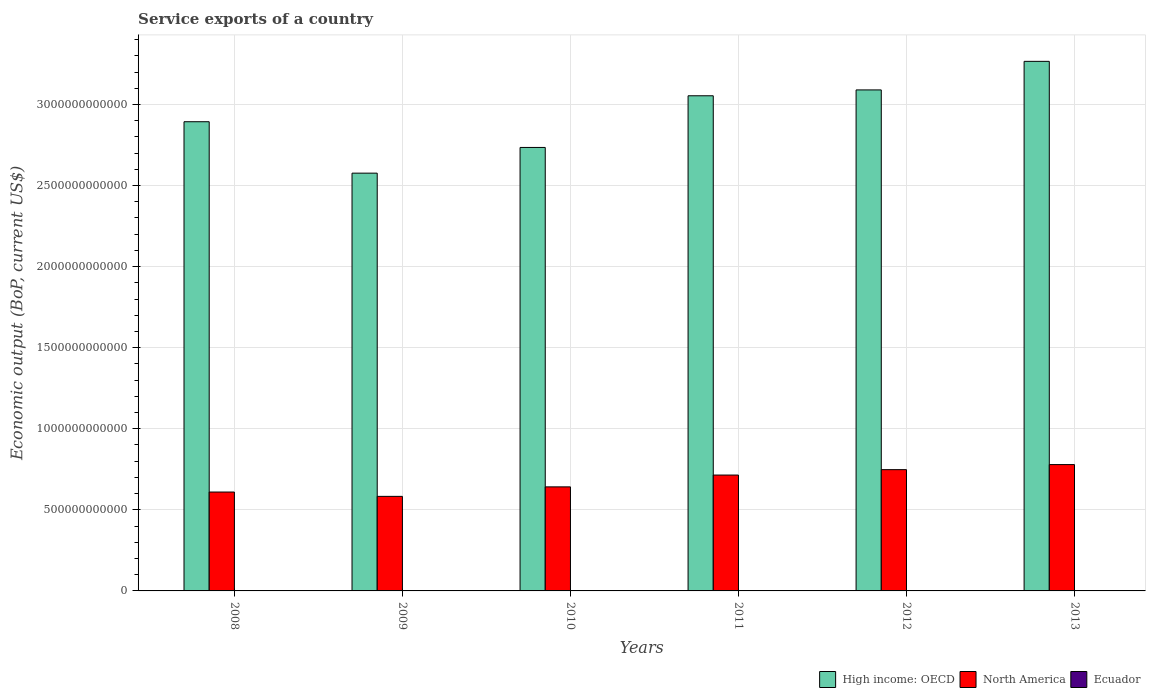How many different coloured bars are there?
Ensure brevity in your answer.  3. Are the number of bars per tick equal to the number of legend labels?
Offer a terse response. Yes. What is the label of the 1st group of bars from the left?
Ensure brevity in your answer.  2008. In how many cases, is the number of bars for a given year not equal to the number of legend labels?
Your answer should be compact. 0. What is the service exports in Ecuador in 2011?
Ensure brevity in your answer.  1.59e+09. Across all years, what is the maximum service exports in North America?
Provide a succinct answer. 7.79e+11. Across all years, what is the minimum service exports in North America?
Your answer should be very brief. 5.83e+11. In which year was the service exports in North America minimum?
Keep it short and to the point. 2009. What is the total service exports in Ecuador in the graph?
Keep it short and to the point. 9.71e+09. What is the difference between the service exports in Ecuador in 2008 and that in 2011?
Keep it short and to the point. -1.46e+08. What is the difference between the service exports in North America in 2011 and the service exports in High income: OECD in 2008?
Provide a succinct answer. -2.18e+12. What is the average service exports in North America per year?
Ensure brevity in your answer.  6.79e+11. In the year 2013, what is the difference between the service exports in High income: OECD and service exports in Ecuador?
Give a very brief answer. 3.26e+12. What is the ratio of the service exports in North America in 2011 to that in 2013?
Ensure brevity in your answer.  0.92. What is the difference between the highest and the second highest service exports in North America?
Offer a terse response. 3.12e+1. What is the difference between the highest and the lowest service exports in North America?
Your answer should be compact. 1.96e+11. In how many years, is the service exports in North America greater than the average service exports in North America taken over all years?
Provide a short and direct response. 3. Is the sum of the service exports in Ecuador in 2011 and 2012 greater than the maximum service exports in High income: OECD across all years?
Your answer should be compact. No. What does the 3rd bar from the left in 2008 represents?
Your answer should be very brief. Ecuador. Is it the case that in every year, the sum of the service exports in High income: OECD and service exports in Ecuador is greater than the service exports in North America?
Offer a very short reply. Yes. Are all the bars in the graph horizontal?
Offer a terse response. No. How many years are there in the graph?
Ensure brevity in your answer.  6. What is the difference between two consecutive major ticks on the Y-axis?
Offer a terse response. 5.00e+11. Are the values on the major ticks of Y-axis written in scientific E-notation?
Give a very brief answer. No. Does the graph contain any zero values?
Give a very brief answer. No. Does the graph contain grids?
Make the answer very short. Yes. How are the legend labels stacked?
Make the answer very short. Horizontal. What is the title of the graph?
Your answer should be very brief. Service exports of a country. What is the label or title of the Y-axis?
Offer a very short reply. Economic output (BoP, current US$). What is the Economic output (BoP, current US$) in High income: OECD in 2008?
Offer a terse response. 2.89e+12. What is the Economic output (BoP, current US$) of North America in 2008?
Your answer should be compact. 6.10e+11. What is the Economic output (BoP, current US$) in Ecuador in 2008?
Give a very brief answer. 1.45e+09. What is the Economic output (BoP, current US$) of High income: OECD in 2009?
Keep it short and to the point. 2.58e+12. What is the Economic output (BoP, current US$) of North America in 2009?
Offer a terse response. 5.83e+11. What is the Economic output (BoP, current US$) of Ecuador in 2009?
Make the answer very short. 1.34e+09. What is the Economic output (BoP, current US$) in High income: OECD in 2010?
Your response must be concise. 2.73e+12. What is the Economic output (BoP, current US$) of North America in 2010?
Ensure brevity in your answer.  6.42e+11. What is the Economic output (BoP, current US$) in Ecuador in 2010?
Provide a short and direct response. 1.48e+09. What is the Economic output (BoP, current US$) in High income: OECD in 2011?
Provide a succinct answer. 3.05e+12. What is the Economic output (BoP, current US$) of North America in 2011?
Your answer should be compact. 7.15e+11. What is the Economic output (BoP, current US$) in Ecuador in 2011?
Your answer should be very brief. 1.59e+09. What is the Economic output (BoP, current US$) of High income: OECD in 2012?
Provide a succinct answer. 3.09e+12. What is the Economic output (BoP, current US$) in North America in 2012?
Ensure brevity in your answer.  7.48e+11. What is the Economic output (BoP, current US$) in Ecuador in 2012?
Your answer should be compact. 1.81e+09. What is the Economic output (BoP, current US$) of High income: OECD in 2013?
Make the answer very short. 3.27e+12. What is the Economic output (BoP, current US$) in North America in 2013?
Offer a very short reply. 7.79e+11. What is the Economic output (BoP, current US$) in Ecuador in 2013?
Provide a short and direct response. 2.04e+09. Across all years, what is the maximum Economic output (BoP, current US$) in High income: OECD?
Your answer should be very brief. 3.27e+12. Across all years, what is the maximum Economic output (BoP, current US$) in North America?
Provide a succinct answer. 7.79e+11. Across all years, what is the maximum Economic output (BoP, current US$) of Ecuador?
Provide a short and direct response. 2.04e+09. Across all years, what is the minimum Economic output (BoP, current US$) of High income: OECD?
Give a very brief answer. 2.58e+12. Across all years, what is the minimum Economic output (BoP, current US$) in North America?
Your answer should be very brief. 5.83e+11. Across all years, what is the minimum Economic output (BoP, current US$) in Ecuador?
Provide a short and direct response. 1.34e+09. What is the total Economic output (BoP, current US$) in High income: OECD in the graph?
Give a very brief answer. 1.76e+13. What is the total Economic output (BoP, current US$) of North America in the graph?
Provide a succinct answer. 4.08e+12. What is the total Economic output (BoP, current US$) in Ecuador in the graph?
Ensure brevity in your answer.  9.71e+09. What is the difference between the Economic output (BoP, current US$) of High income: OECD in 2008 and that in 2009?
Ensure brevity in your answer.  3.17e+11. What is the difference between the Economic output (BoP, current US$) in North America in 2008 and that in 2009?
Offer a very short reply. 2.67e+1. What is the difference between the Economic output (BoP, current US$) of Ecuador in 2008 and that in 2009?
Offer a very short reply. 1.05e+08. What is the difference between the Economic output (BoP, current US$) in High income: OECD in 2008 and that in 2010?
Your answer should be very brief. 1.59e+11. What is the difference between the Economic output (BoP, current US$) of North America in 2008 and that in 2010?
Ensure brevity in your answer.  -3.19e+1. What is the difference between the Economic output (BoP, current US$) of Ecuador in 2008 and that in 2010?
Your answer should be very brief. -3.06e+07. What is the difference between the Economic output (BoP, current US$) of High income: OECD in 2008 and that in 2011?
Your response must be concise. -1.60e+11. What is the difference between the Economic output (BoP, current US$) of North America in 2008 and that in 2011?
Offer a terse response. -1.05e+11. What is the difference between the Economic output (BoP, current US$) of Ecuador in 2008 and that in 2011?
Keep it short and to the point. -1.46e+08. What is the difference between the Economic output (BoP, current US$) of High income: OECD in 2008 and that in 2012?
Provide a short and direct response. -1.96e+11. What is the difference between the Economic output (BoP, current US$) in North America in 2008 and that in 2012?
Offer a terse response. -1.38e+11. What is the difference between the Economic output (BoP, current US$) of Ecuador in 2008 and that in 2012?
Provide a succinct answer. -3.66e+08. What is the difference between the Economic output (BoP, current US$) of High income: OECD in 2008 and that in 2013?
Your answer should be compact. -3.72e+11. What is the difference between the Economic output (BoP, current US$) in North America in 2008 and that in 2013?
Your response must be concise. -1.69e+11. What is the difference between the Economic output (BoP, current US$) of Ecuador in 2008 and that in 2013?
Ensure brevity in your answer.  -5.88e+08. What is the difference between the Economic output (BoP, current US$) in High income: OECD in 2009 and that in 2010?
Keep it short and to the point. -1.58e+11. What is the difference between the Economic output (BoP, current US$) in North America in 2009 and that in 2010?
Keep it short and to the point. -5.86e+1. What is the difference between the Economic output (BoP, current US$) in Ecuador in 2009 and that in 2010?
Ensure brevity in your answer.  -1.36e+08. What is the difference between the Economic output (BoP, current US$) in High income: OECD in 2009 and that in 2011?
Offer a terse response. -4.77e+11. What is the difference between the Economic output (BoP, current US$) of North America in 2009 and that in 2011?
Offer a very short reply. -1.31e+11. What is the difference between the Economic output (BoP, current US$) of Ecuador in 2009 and that in 2011?
Offer a terse response. -2.51e+08. What is the difference between the Economic output (BoP, current US$) in High income: OECD in 2009 and that in 2012?
Provide a short and direct response. -5.13e+11. What is the difference between the Economic output (BoP, current US$) in North America in 2009 and that in 2012?
Ensure brevity in your answer.  -1.65e+11. What is the difference between the Economic output (BoP, current US$) in Ecuador in 2009 and that in 2012?
Offer a very short reply. -4.71e+08. What is the difference between the Economic output (BoP, current US$) in High income: OECD in 2009 and that in 2013?
Your answer should be very brief. -6.89e+11. What is the difference between the Economic output (BoP, current US$) of North America in 2009 and that in 2013?
Make the answer very short. -1.96e+11. What is the difference between the Economic output (BoP, current US$) in Ecuador in 2009 and that in 2013?
Make the answer very short. -6.93e+08. What is the difference between the Economic output (BoP, current US$) of High income: OECD in 2010 and that in 2011?
Keep it short and to the point. -3.19e+11. What is the difference between the Economic output (BoP, current US$) in North America in 2010 and that in 2011?
Provide a succinct answer. -7.29e+1. What is the difference between the Economic output (BoP, current US$) of Ecuador in 2010 and that in 2011?
Ensure brevity in your answer.  -1.15e+08. What is the difference between the Economic output (BoP, current US$) in High income: OECD in 2010 and that in 2012?
Provide a succinct answer. -3.55e+11. What is the difference between the Economic output (BoP, current US$) of North America in 2010 and that in 2012?
Keep it short and to the point. -1.06e+11. What is the difference between the Economic output (BoP, current US$) of Ecuador in 2010 and that in 2012?
Offer a terse response. -3.35e+08. What is the difference between the Economic output (BoP, current US$) of High income: OECD in 2010 and that in 2013?
Make the answer very short. -5.31e+11. What is the difference between the Economic output (BoP, current US$) of North America in 2010 and that in 2013?
Provide a short and direct response. -1.37e+11. What is the difference between the Economic output (BoP, current US$) of Ecuador in 2010 and that in 2013?
Offer a terse response. -5.57e+08. What is the difference between the Economic output (BoP, current US$) of High income: OECD in 2011 and that in 2012?
Your answer should be very brief. -3.62e+1. What is the difference between the Economic output (BoP, current US$) in North America in 2011 and that in 2012?
Provide a succinct answer. -3.33e+1. What is the difference between the Economic output (BoP, current US$) in Ecuador in 2011 and that in 2012?
Provide a succinct answer. -2.20e+08. What is the difference between the Economic output (BoP, current US$) in High income: OECD in 2011 and that in 2013?
Give a very brief answer. -2.12e+11. What is the difference between the Economic output (BoP, current US$) in North America in 2011 and that in 2013?
Your response must be concise. -6.46e+1. What is the difference between the Economic output (BoP, current US$) in Ecuador in 2011 and that in 2013?
Your answer should be very brief. -4.42e+08. What is the difference between the Economic output (BoP, current US$) in High income: OECD in 2012 and that in 2013?
Offer a very short reply. -1.76e+11. What is the difference between the Economic output (BoP, current US$) in North America in 2012 and that in 2013?
Offer a very short reply. -3.12e+1. What is the difference between the Economic output (BoP, current US$) of Ecuador in 2012 and that in 2013?
Give a very brief answer. -2.22e+08. What is the difference between the Economic output (BoP, current US$) of High income: OECD in 2008 and the Economic output (BoP, current US$) of North America in 2009?
Ensure brevity in your answer.  2.31e+12. What is the difference between the Economic output (BoP, current US$) in High income: OECD in 2008 and the Economic output (BoP, current US$) in Ecuador in 2009?
Provide a succinct answer. 2.89e+12. What is the difference between the Economic output (BoP, current US$) of North America in 2008 and the Economic output (BoP, current US$) of Ecuador in 2009?
Make the answer very short. 6.08e+11. What is the difference between the Economic output (BoP, current US$) of High income: OECD in 2008 and the Economic output (BoP, current US$) of North America in 2010?
Provide a succinct answer. 2.25e+12. What is the difference between the Economic output (BoP, current US$) of High income: OECD in 2008 and the Economic output (BoP, current US$) of Ecuador in 2010?
Your response must be concise. 2.89e+12. What is the difference between the Economic output (BoP, current US$) in North America in 2008 and the Economic output (BoP, current US$) in Ecuador in 2010?
Your answer should be very brief. 6.08e+11. What is the difference between the Economic output (BoP, current US$) in High income: OECD in 2008 and the Economic output (BoP, current US$) in North America in 2011?
Provide a succinct answer. 2.18e+12. What is the difference between the Economic output (BoP, current US$) in High income: OECD in 2008 and the Economic output (BoP, current US$) in Ecuador in 2011?
Your answer should be very brief. 2.89e+12. What is the difference between the Economic output (BoP, current US$) of North America in 2008 and the Economic output (BoP, current US$) of Ecuador in 2011?
Ensure brevity in your answer.  6.08e+11. What is the difference between the Economic output (BoP, current US$) of High income: OECD in 2008 and the Economic output (BoP, current US$) of North America in 2012?
Make the answer very short. 2.15e+12. What is the difference between the Economic output (BoP, current US$) in High income: OECD in 2008 and the Economic output (BoP, current US$) in Ecuador in 2012?
Ensure brevity in your answer.  2.89e+12. What is the difference between the Economic output (BoP, current US$) in North America in 2008 and the Economic output (BoP, current US$) in Ecuador in 2012?
Ensure brevity in your answer.  6.08e+11. What is the difference between the Economic output (BoP, current US$) of High income: OECD in 2008 and the Economic output (BoP, current US$) of North America in 2013?
Make the answer very short. 2.11e+12. What is the difference between the Economic output (BoP, current US$) in High income: OECD in 2008 and the Economic output (BoP, current US$) in Ecuador in 2013?
Provide a succinct answer. 2.89e+12. What is the difference between the Economic output (BoP, current US$) of North America in 2008 and the Economic output (BoP, current US$) of Ecuador in 2013?
Your answer should be compact. 6.08e+11. What is the difference between the Economic output (BoP, current US$) in High income: OECD in 2009 and the Economic output (BoP, current US$) in North America in 2010?
Give a very brief answer. 1.93e+12. What is the difference between the Economic output (BoP, current US$) of High income: OECD in 2009 and the Economic output (BoP, current US$) of Ecuador in 2010?
Provide a short and direct response. 2.57e+12. What is the difference between the Economic output (BoP, current US$) in North America in 2009 and the Economic output (BoP, current US$) in Ecuador in 2010?
Offer a very short reply. 5.82e+11. What is the difference between the Economic output (BoP, current US$) in High income: OECD in 2009 and the Economic output (BoP, current US$) in North America in 2011?
Give a very brief answer. 1.86e+12. What is the difference between the Economic output (BoP, current US$) in High income: OECD in 2009 and the Economic output (BoP, current US$) in Ecuador in 2011?
Your answer should be compact. 2.57e+12. What is the difference between the Economic output (BoP, current US$) in North America in 2009 and the Economic output (BoP, current US$) in Ecuador in 2011?
Your answer should be compact. 5.81e+11. What is the difference between the Economic output (BoP, current US$) of High income: OECD in 2009 and the Economic output (BoP, current US$) of North America in 2012?
Offer a very short reply. 1.83e+12. What is the difference between the Economic output (BoP, current US$) of High income: OECD in 2009 and the Economic output (BoP, current US$) of Ecuador in 2012?
Ensure brevity in your answer.  2.57e+12. What is the difference between the Economic output (BoP, current US$) in North America in 2009 and the Economic output (BoP, current US$) in Ecuador in 2012?
Provide a short and direct response. 5.81e+11. What is the difference between the Economic output (BoP, current US$) of High income: OECD in 2009 and the Economic output (BoP, current US$) of North America in 2013?
Provide a succinct answer. 1.80e+12. What is the difference between the Economic output (BoP, current US$) of High income: OECD in 2009 and the Economic output (BoP, current US$) of Ecuador in 2013?
Give a very brief answer. 2.57e+12. What is the difference between the Economic output (BoP, current US$) of North America in 2009 and the Economic output (BoP, current US$) of Ecuador in 2013?
Your response must be concise. 5.81e+11. What is the difference between the Economic output (BoP, current US$) in High income: OECD in 2010 and the Economic output (BoP, current US$) in North America in 2011?
Give a very brief answer. 2.02e+12. What is the difference between the Economic output (BoP, current US$) in High income: OECD in 2010 and the Economic output (BoP, current US$) in Ecuador in 2011?
Your answer should be compact. 2.73e+12. What is the difference between the Economic output (BoP, current US$) of North America in 2010 and the Economic output (BoP, current US$) of Ecuador in 2011?
Keep it short and to the point. 6.40e+11. What is the difference between the Economic output (BoP, current US$) in High income: OECD in 2010 and the Economic output (BoP, current US$) in North America in 2012?
Make the answer very short. 1.99e+12. What is the difference between the Economic output (BoP, current US$) in High income: OECD in 2010 and the Economic output (BoP, current US$) in Ecuador in 2012?
Make the answer very short. 2.73e+12. What is the difference between the Economic output (BoP, current US$) of North America in 2010 and the Economic output (BoP, current US$) of Ecuador in 2012?
Keep it short and to the point. 6.40e+11. What is the difference between the Economic output (BoP, current US$) in High income: OECD in 2010 and the Economic output (BoP, current US$) in North America in 2013?
Your response must be concise. 1.96e+12. What is the difference between the Economic output (BoP, current US$) in High income: OECD in 2010 and the Economic output (BoP, current US$) in Ecuador in 2013?
Provide a short and direct response. 2.73e+12. What is the difference between the Economic output (BoP, current US$) of North America in 2010 and the Economic output (BoP, current US$) of Ecuador in 2013?
Give a very brief answer. 6.40e+11. What is the difference between the Economic output (BoP, current US$) in High income: OECD in 2011 and the Economic output (BoP, current US$) in North America in 2012?
Your response must be concise. 2.31e+12. What is the difference between the Economic output (BoP, current US$) in High income: OECD in 2011 and the Economic output (BoP, current US$) in Ecuador in 2012?
Ensure brevity in your answer.  3.05e+12. What is the difference between the Economic output (BoP, current US$) in North America in 2011 and the Economic output (BoP, current US$) in Ecuador in 2012?
Your answer should be compact. 7.13e+11. What is the difference between the Economic output (BoP, current US$) of High income: OECD in 2011 and the Economic output (BoP, current US$) of North America in 2013?
Offer a very short reply. 2.27e+12. What is the difference between the Economic output (BoP, current US$) in High income: OECD in 2011 and the Economic output (BoP, current US$) in Ecuador in 2013?
Offer a very short reply. 3.05e+12. What is the difference between the Economic output (BoP, current US$) of North America in 2011 and the Economic output (BoP, current US$) of Ecuador in 2013?
Make the answer very short. 7.13e+11. What is the difference between the Economic output (BoP, current US$) in High income: OECD in 2012 and the Economic output (BoP, current US$) in North America in 2013?
Your response must be concise. 2.31e+12. What is the difference between the Economic output (BoP, current US$) in High income: OECD in 2012 and the Economic output (BoP, current US$) in Ecuador in 2013?
Your response must be concise. 3.09e+12. What is the difference between the Economic output (BoP, current US$) of North America in 2012 and the Economic output (BoP, current US$) of Ecuador in 2013?
Give a very brief answer. 7.46e+11. What is the average Economic output (BoP, current US$) of High income: OECD per year?
Give a very brief answer. 2.94e+12. What is the average Economic output (BoP, current US$) in North America per year?
Your answer should be very brief. 6.79e+11. What is the average Economic output (BoP, current US$) of Ecuador per year?
Give a very brief answer. 1.62e+09. In the year 2008, what is the difference between the Economic output (BoP, current US$) in High income: OECD and Economic output (BoP, current US$) in North America?
Make the answer very short. 2.28e+12. In the year 2008, what is the difference between the Economic output (BoP, current US$) in High income: OECD and Economic output (BoP, current US$) in Ecuador?
Give a very brief answer. 2.89e+12. In the year 2008, what is the difference between the Economic output (BoP, current US$) of North America and Economic output (BoP, current US$) of Ecuador?
Your answer should be very brief. 6.08e+11. In the year 2009, what is the difference between the Economic output (BoP, current US$) of High income: OECD and Economic output (BoP, current US$) of North America?
Your answer should be compact. 1.99e+12. In the year 2009, what is the difference between the Economic output (BoP, current US$) of High income: OECD and Economic output (BoP, current US$) of Ecuador?
Make the answer very short. 2.58e+12. In the year 2009, what is the difference between the Economic output (BoP, current US$) in North America and Economic output (BoP, current US$) in Ecuador?
Your answer should be compact. 5.82e+11. In the year 2010, what is the difference between the Economic output (BoP, current US$) in High income: OECD and Economic output (BoP, current US$) in North America?
Your answer should be compact. 2.09e+12. In the year 2010, what is the difference between the Economic output (BoP, current US$) in High income: OECD and Economic output (BoP, current US$) in Ecuador?
Provide a succinct answer. 2.73e+12. In the year 2010, what is the difference between the Economic output (BoP, current US$) of North America and Economic output (BoP, current US$) of Ecuador?
Your response must be concise. 6.40e+11. In the year 2011, what is the difference between the Economic output (BoP, current US$) in High income: OECD and Economic output (BoP, current US$) in North America?
Keep it short and to the point. 2.34e+12. In the year 2011, what is the difference between the Economic output (BoP, current US$) in High income: OECD and Economic output (BoP, current US$) in Ecuador?
Your answer should be very brief. 3.05e+12. In the year 2011, what is the difference between the Economic output (BoP, current US$) in North America and Economic output (BoP, current US$) in Ecuador?
Your answer should be very brief. 7.13e+11. In the year 2012, what is the difference between the Economic output (BoP, current US$) in High income: OECD and Economic output (BoP, current US$) in North America?
Your answer should be very brief. 2.34e+12. In the year 2012, what is the difference between the Economic output (BoP, current US$) in High income: OECD and Economic output (BoP, current US$) in Ecuador?
Your answer should be very brief. 3.09e+12. In the year 2012, what is the difference between the Economic output (BoP, current US$) in North America and Economic output (BoP, current US$) in Ecuador?
Your answer should be very brief. 7.46e+11. In the year 2013, what is the difference between the Economic output (BoP, current US$) in High income: OECD and Economic output (BoP, current US$) in North America?
Ensure brevity in your answer.  2.49e+12. In the year 2013, what is the difference between the Economic output (BoP, current US$) of High income: OECD and Economic output (BoP, current US$) of Ecuador?
Your answer should be very brief. 3.26e+12. In the year 2013, what is the difference between the Economic output (BoP, current US$) of North America and Economic output (BoP, current US$) of Ecuador?
Make the answer very short. 7.77e+11. What is the ratio of the Economic output (BoP, current US$) of High income: OECD in 2008 to that in 2009?
Offer a very short reply. 1.12. What is the ratio of the Economic output (BoP, current US$) of North America in 2008 to that in 2009?
Your response must be concise. 1.05. What is the ratio of the Economic output (BoP, current US$) in Ecuador in 2008 to that in 2009?
Give a very brief answer. 1.08. What is the ratio of the Economic output (BoP, current US$) of High income: OECD in 2008 to that in 2010?
Offer a terse response. 1.06. What is the ratio of the Economic output (BoP, current US$) of North America in 2008 to that in 2010?
Your answer should be compact. 0.95. What is the ratio of the Economic output (BoP, current US$) of Ecuador in 2008 to that in 2010?
Give a very brief answer. 0.98. What is the ratio of the Economic output (BoP, current US$) of High income: OECD in 2008 to that in 2011?
Your answer should be very brief. 0.95. What is the ratio of the Economic output (BoP, current US$) in North America in 2008 to that in 2011?
Provide a short and direct response. 0.85. What is the ratio of the Economic output (BoP, current US$) of Ecuador in 2008 to that in 2011?
Your answer should be compact. 0.91. What is the ratio of the Economic output (BoP, current US$) of High income: OECD in 2008 to that in 2012?
Offer a very short reply. 0.94. What is the ratio of the Economic output (BoP, current US$) in North America in 2008 to that in 2012?
Offer a very short reply. 0.82. What is the ratio of the Economic output (BoP, current US$) in Ecuador in 2008 to that in 2012?
Make the answer very short. 0.8. What is the ratio of the Economic output (BoP, current US$) of High income: OECD in 2008 to that in 2013?
Your answer should be very brief. 0.89. What is the ratio of the Economic output (BoP, current US$) of North America in 2008 to that in 2013?
Give a very brief answer. 0.78. What is the ratio of the Economic output (BoP, current US$) in Ecuador in 2008 to that in 2013?
Give a very brief answer. 0.71. What is the ratio of the Economic output (BoP, current US$) of High income: OECD in 2009 to that in 2010?
Your answer should be compact. 0.94. What is the ratio of the Economic output (BoP, current US$) of North America in 2009 to that in 2010?
Your answer should be compact. 0.91. What is the ratio of the Economic output (BoP, current US$) in Ecuador in 2009 to that in 2010?
Provide a short and direct response. 0.91. What is the ratio of the Economic output (BoP, current US$) in High income: OECD in 2009 to that in 2011?
Give a very brief answer. 0.84. What is the ratio of the Economic output (BoP, current US$) of North America in 2009 to that in 2011?
Your answer should be compact. 0.82. What is the ratio of the Economic output (BoP, current US$) in Ecuador in 2009 to that in 2011?
Offer a terse response. 0.84. What is the ratio of the Economic output (BoP, current US$) in High income: OECD in 2009 to that in 2012?
Give a very brief answer. 0.83. What is the ratio of the Economic output (BoP, current US$) of North America in 2009 to that in 2012?
Ensure brevity in your answer.  0.78. What is the ratio of the Economic output (BoP, current US$) of Ecuador in 2009 to that in 2012?
Provide a short and direct response. 0.74. What is the ratio of the Economic output (BoP, current US$) of High income: OECD in 2009 to that in 2013?
Make the answer very short. 0.79. What is the ratio of the Economic output (BoP, current US$) in North America in 2009 to that in 2013?
Your response must be concise. 0.75. What is the ratio of the Economic output (BoP, current US$) of Ecuador in 2009 to that in 2013?
Ensure brevity in your answer.  0.66. What is the ratio of the Economic output (BoP, current US$) in High income: OECD in 2010 to that in 2011?
Your answer should be very brief. 0.9. What is the ratio of the Economic output (BoP, current US$) of North America in 2010 to that in 2011?
Ensure brevity in your answer.  0.9. What is the ratio of the Economic output (BoP, current US$) of Ecuador in 2010 to that in 2011?
Give a very brief answer. 0.93. What is the ratio of the Economic output (BoP, current US$) of High income: OECD in 2010 to that in 2012?
Ensure brevity in your answer.  0.89. What is the ratio of the Economic output (BoP, current US$) in North America in 2010 to that in 2012?
Ensure brevity in your answer.  0.86. What is the ratio of the Economic output (BoP, current US$) of Ecuador in 2010 to that in 2012?
Your response must be concise. 0.82. What is the ratio of the Economic output (BoP, current US$) of High income: OECD in 2010 to that in 2013?
Your answer should be compact. 0.84. What is the ratio of the Economic output (BoP, current US$) in North America in 2010 to that in 2013?
Offer a very short reply. 0.82. What is the ratio of the Economic output (BoP, current US$) of Ecuador in 2010 to that in 2013?
Keep it short and to the point. 0.73. What is the ratio of the Economic output (BoP, current US$) in High income: OECD in 2011 to that in 2012?
Your answer should be very brief. 0.99. What is the ratio of the Economic output (BoP, current US$) of North America in 2011 to that in 2012?
Give a very brief answer. 0.96. What is the ratio of the Economic output (BoP, current US$) of Ecuador in 2011 to that in 2012?
Make the answer very short. 0.88. What is the ratio of the Economic output (BoP, current US$) in High income: OECD in 2011 to that in 2013?
Give a very brief answer. 0.94. What is the ratio of the Economic output (BoP, current US$) of North America in 2011 to that in 2013?
Make the answer very short. 0.92. What is the ratio of the Economic output (BoP, current US$) in Ecuador in 2011 to that in 2013?
Give a very brief answer. 0.78. What is the ratio of the Economic output (BoP, current US$) of High income: OECD in 2012 to that in 2013?
Make the answer very short. 0.95. What is the ratio of the Economic output (BoP, current US$) in North America in 2012 to that in 2013?
Give a very brief answer. 0.96. What is the ratio of the Economic output (BoP, current US$) in Ecuador in 2012 to that in 2013?
Your answer should be compact. 0.89. What is the difference between the highest and the second highest Economic output (BoP, current US$) of High income: OECD?
Give a very brief answer. 1.76e+11. What is the difference between the highest and the second highest Economic output (BoP, current US$) in North America?
Keep it short and to the point. 3.12e+1. What is the difference between the highest and the second highest Economic output (BoP, current US$) of Ecuador?
Your response must be concise. 2.22e+08. What is the difference between the highest and the lowest Economic output (BoP, current US$) of High income: OECD?
Provide a succinct answer. 6.89e+11. What is the difference between the highest and the lowest Economic output (BoP, current US$) of North America?
Keep it short and to the point. 1.96e+11. What is the difference between the highest and the lowest Economic output (BoP, current US$) in Ecuador?
Keep it short and to the point. 6.93e+08. 